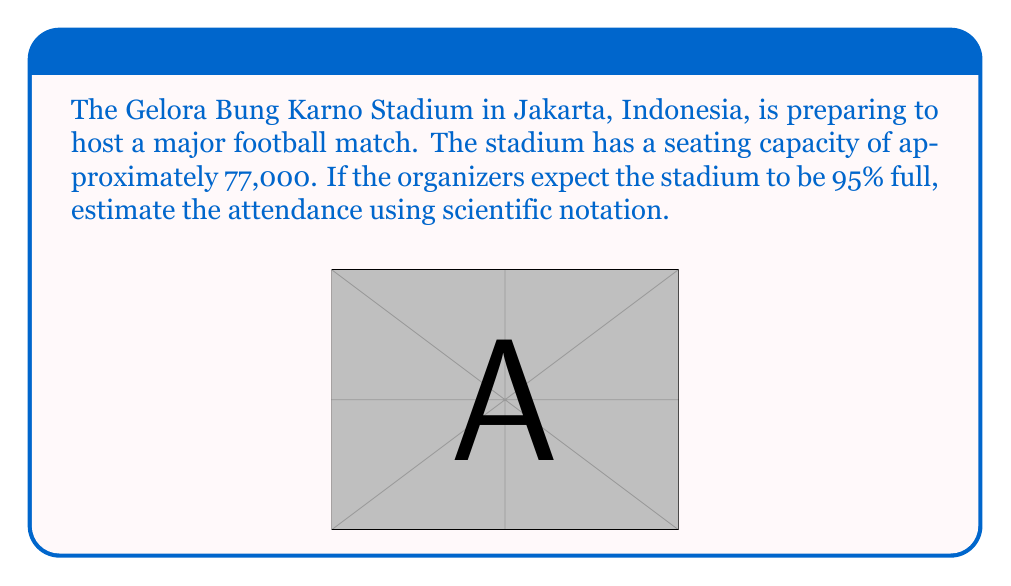Solve this math problem. Let's approach this step-by-step:

1) First, we need to calculate 95% of 77,000.

2) To do this, we convert 95% to a decimal: 95% = 0.95

3) Now, we multiply:
   $77,000 \times 0.95 = 73,150$

4) To express this in scientific notation, we need to move the decimal point to have a number between 1 and 10, followed by $\times 10^n$

5) Moving the decimal point 4 places to the left gives us:
   $73,150 = 7.3150 \times 10^4$

6) We can round this to two decimal places:
   $7.32 \times 10^4$

Therefore, the estimated attendance, expressed in scientific notation, is $7.32 \times 10^4$.
Answer: $7.32 \times 10^4$ 